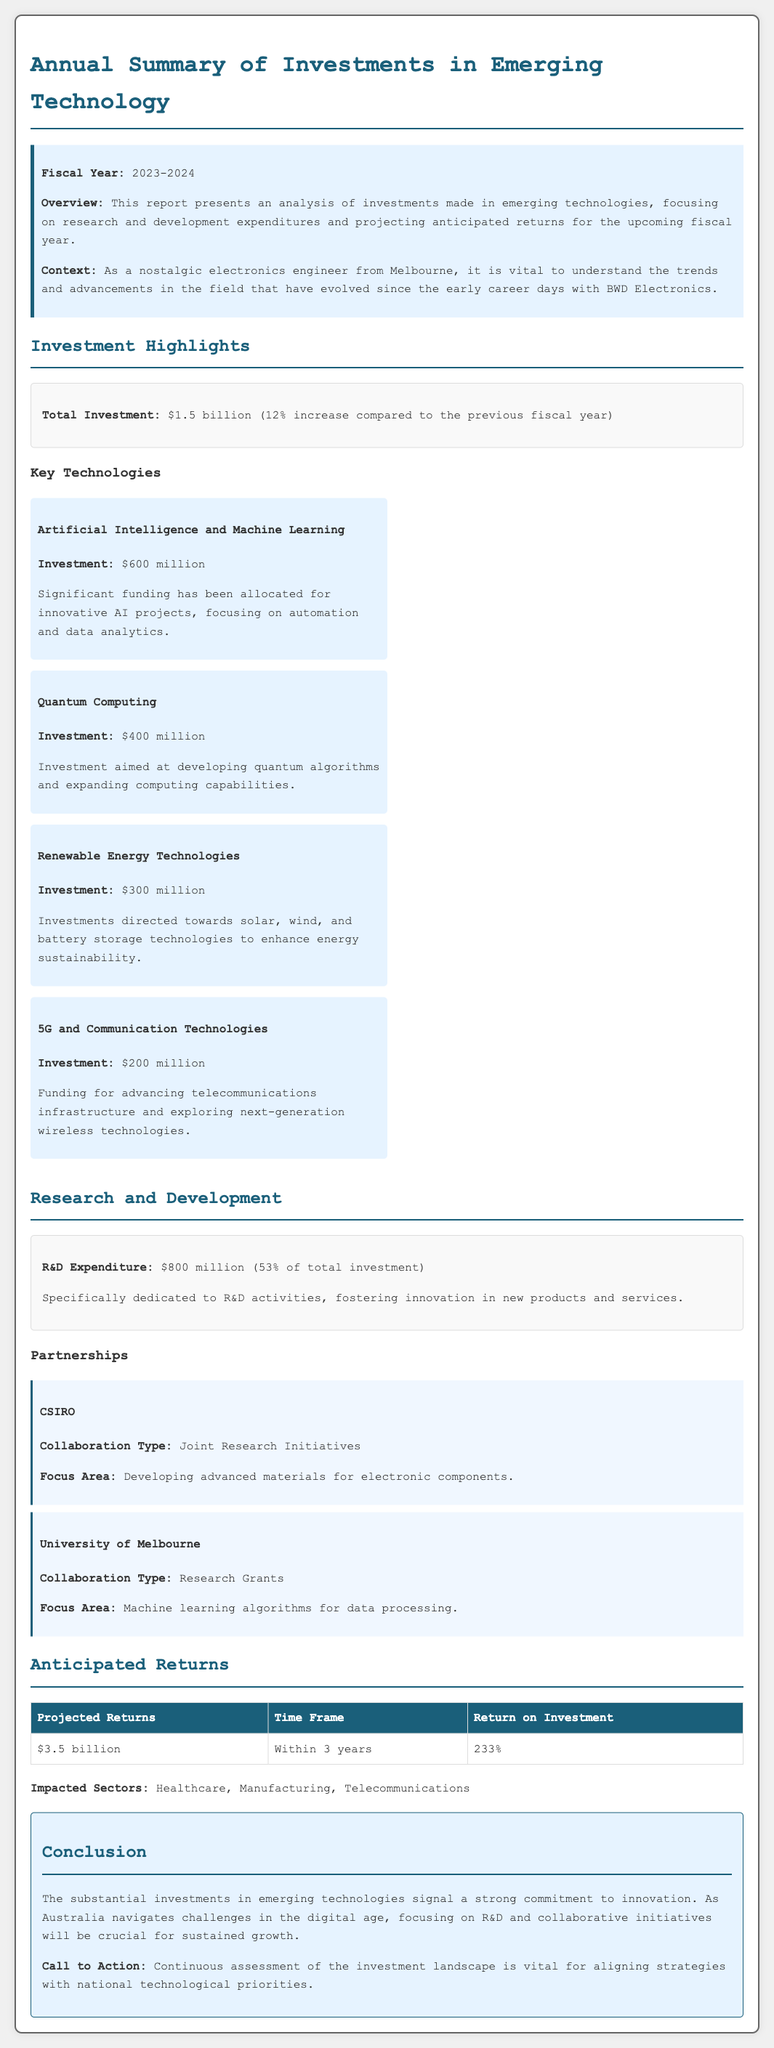what is the total investment? The total investment is provided in the report, indicating a 12% increase from the previous fiscal year.
Answer: $1.5 billion how much is spent on research and development? The document states the expenditure on R&D specifically allocated to innovation and development.
Answer: $800 million what is the anticipated return on investment? The anticipated return on investment is listed in the projector returns table.
Answer: 233% which sector is impacted by these investments? The impacted sectors are identified in the anticipated returns section of the document.
Answer: Healthcare, Manufacturing, Telecommunications who is collaborating with CSIRO? The document identifies specific collaborations focused on research and innovations.
Answer: University of Melbourne how much was invested in artificial intelligence and machine learning? The report details financial allocations for key technologies and their respective investments.
Answer: $600 million 